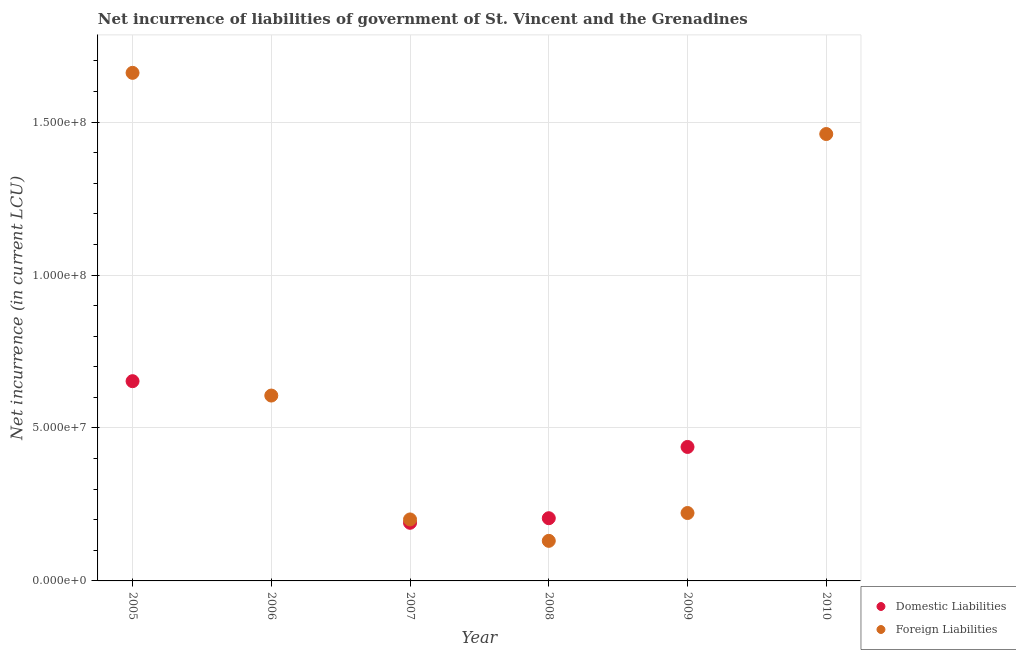Is the number of dotlines equal to the number of legend labels?
Make the answer very short. No. What is the net incurrence of foreign liabilities in 2009?
Provide a short and direct response. 2.22e+07. Across all years, what is the maximum net incurrence of foreign liabilities?
Offer a terse response. 1.66e+08. Across all years, what is the minimum net incurrence of foreign liabilities?
Ensure brevity in your answer.  1.31e+07. In which year was the net incurrence of foreign liabilities maximum?
Offer a very short reply. 2005. What is the total net incurrence of domestic liabilities in the graph?
Ensure brevity in your answer.  1.49e+08. What is the difference between the net incurrence of foreign liabilities in 2005 and that in 2006?
Ensure brevity in your answer.  1.06e+08. What is the difference between the net incurrence of foreign liabilities in 2010 and the net incurrence of domestic liabilities in 2006?
Ensure brevity in your answer.  1.46e+08. What is the average net incurrence of foreign liabilities per year?
Ensure brevity in your answer.  7.14e+07. In the year 2008, what is the difference between the net incurrence of domestic liabilities and net incurrence of foreign liabilities?
Your answer should be compact. 7.40e+06. In how many years, is the net incurrence of domestic liabilities greater than 160000000 LCU?
Your answer should be compact. 0. What is the ratio of the net incurrence of foreign liabilities in 2007 to that in 2010?
Keep it short and to the point. 0.14. Is the net incurrence of domestic liabilities in 2008 less than that in 2009?
Make the answer very short. Yes. What is the difference between the highest and the second highest net incurrence of domestic liabilities?
Offer a very short reply. 2.15e+07. What is the difference between the highest and the lowest net incurrence of foreign liabilities?
Offer a terse response. 1.53e+08. In how many years, is the net incurrence of domestic liabilities greater than the average net incurrence of domestic liabilities taken over all years?
Offer a very short reply. 2. Is the sum of the net incurrence of foreign liabilities in 2005 and 2010 greater than the maximum net incurrence of domestic liabilities across all years?
Provide a succinct answer. Yes. Does the net incurrence of foreign liabilities monotonically increase over the years?
Ensure brevity in your answer.  No. Is the net incurrence of domestic liabilities strictly greater than the net incurrence of foreign liabilities over the years?
Offer a terse response. No. Is the net incurrence of foreign liabilities strictly less than the net incurrence of domestic liabilities over the years?
Keep it short and to the point. No. What is the difference between two consecutive major ticks on the Y-axis?
Ensure brevity in your answer.  5.00e+07. Are the values on the major ticks of Y-axis written in scientific E-notation?
Your answer should be compact. Yes. What is the title of the graph?
Your response must be concise. Net incurrence of liabilities of government of St. Vincent and the Grenadines. Does "2012 US$" appear as one of the legend labels in the graph?
Provide a short and direct response. No. What is the label or title of the Y-axis?
Your answer should be compact. Net incurrence (in current LCU). What is the Net incurrence (in current LCU) in Domestic Liabilities in 2005?
Your answer should be very brief. 6.53e+07. What is the Net incurrence (in current LCU) in Foreign Liabilities in 2005?
Ensure brevity in your answer.  1.66e+08. What is the Net incurrence (in current LCU) of Domestic Liabilities in 2006?
Provide a short and direct response. 0. What is the Net incurrence (in current LCU) of Foreign Liabilities in 2006?
Provide a succinct answer. 6.06e+07. What is the Net incurrence (in current LCU) in Domestic Liabilities in 2007?
Give a very brief answer. 1.90e+07. What is the Net incurrence (in current LCU) of Foreign Liabilities in 2007?
Provide a succinct answer. 2.01e+07. What is the Net incurrence (in current LCU) in Domestic Liabilities in 2008?
Keep it short and to the point. 2.05e+07. What is the Net incurrence (in current LCU) of Foreign Liabilities in 2008?
Your answer should be compact. 1.31e+07. What is the Net incurrence (in current LCU) of Domestic Liabilities in 2009?
Keep it short and to the point. 4.38e+07. What is the Net incurrence (in current LCU) of Foreign Liabilities in 2009?
Your answer should be very brief. 2.22e+07. What is the Net incurrence (in current LCU) in Foreign Liabilities in 2010?
Your answer should be very brief. 1.46e+08. Across all years, what is the maximum Net incurrence (in current LCU) of Domestic Liabilities?
Your answer should be compact. 6.53e+07. Across all years, what is the maximum Net incurrence (in current LCU) of Foreign Liabilities?
Make the answer very short. 1.66e+08. Across all years, what is the minimum Net incurrence (in current LCU) in Domestic Liabilities?
Provide a succinct answer. 0. Across all years, what is the minimum Net incurrence (in current LCU) in Foreign Liabilities?
Make the answer very short. 1.31e+07. What is the total Net incurrence (in current LCU) in Domestic Liabilities in the graph?
Your response must be concise. 1.49e+08. What is the total Net incurrence (in current LCU) in Foreign Liabilities in the graph?
Provide a short and direct response. 4.28e+08. What is the difference between the Net incurrence (in current LCU) in Foreign Liabilities in 2005 and that in 2006?
Your answer should be very brief. 1.06e+08. What is the difference between the Net incurrence (in current LCU) in Domestic Liabilities in 2005 and that in 2007?
Ensure brevity in your answer.  4.63e+07. What is the difference between the Net incurrence (in current LCU) in Foreign Liabilities in 2005 and that in 2007?
Offer a very short reply. 1.46e+08. What is the difference between the Net incurrence (in current LCU) in Domestic Liabilities in 2005 and that in 2008?
Give a very brief answer. 4.48e+07. What is the difference between the Net incurrence (in current LCU) in Foreign Liabilities in 2005 and that in 2008?
Your answer should be very brief. 1.53e+08. What is the difference between the Net incurrence (in current LCU) in Domestic Liabilities in 2005 and that in 2009?
Your answer should be compact. 2.15e+07. What is the difference between the Net incurrence (in current LCU) in Foreign Liabilities in 2005 and that in 2009?
Provide a short and direct response. 1.44e+08. What is the difference between the Net incurrence (in current LCU) of Foreign Liabilities in 2006 and that in 2007?
Keep it short and to the point. 4.05e+07. What is the difference between the Net incurrence (in current LCU) of Foreign Liabilities in 2006 and that in 2008?
Provide a succinct answer. 4.75e+07. What is the difference between the Net incurrence (in current LCU) of Foreign Liabilities in 2006 and that in 2009?
Keep it short and to the point. 3.84e+07. What is the difference between the Net incurrence (in current LCU) of Foreign Liabilities in 2006 and that in 2010?
Your answer should be very brief. -8.55e+07. What is the difference between the Net incurrence (in current LCU) in Domestic Liabilities in 2007 and that in 2008?
Provide a succinct answer. -1.50e+06. What is the difference between the Net incurrence (in current LCU) in Foreign Liabilities in 2007 and that in 2008?
Keep it short and to the point. 7.00e+06. What is the difference between the Net incurrence (in current LCU) in Domestic Liabilities in 2007 and that in 2009?
Provide a short and direct response. -2.48e+07. What is the difference between the Net incurrence (in current LCU) of Foreign Liabilities in 2007 and that in 2009?
Ensure brevity in your answer.  -2.10e+06. What is the difference between the Net incurrence (in current LCU) in Foreign Liabilities in 2007 and that in 2010?
Keep it short and to the point. -1.26e+08. What is the difference between the Net incurrence (in current LCU) in Domestic Liabilities in 2008 and that in 2009?
Ensure brevity in your answer.  -2.33e+07. What is the difference between the Net incurrence (in current LCU) in Foreign Liabilities in 2008 and that in 2009?
Make the answer very short. -9.10e+06. What is the difference between the Net incurrence (in current LCU) of Foreign Liabilities in 2008 and that in 2010?
Make the answer very short. -1.33e+08. What is the difference between the Net incurrence (in current LCU) in Foreign Liabilities in 2009 and that in 2010?
Your response must be concise. -1.24e+08. What is the difference between the Net incurrence (in current LCU) of Domestic Liabilities in 2005 and the Net incurrence (in current LCU) of Foreign Liabilities in 2006?
Your answer should be compact. 4.70e+06. What is the difference between the Net incurrence (in current LCU) in Domestic Liabilities in 2005 and the Net incurrence (in current LCU) in Foreign Liabilities in 2007?
Your answer should be very brief. 4.52e+07. What is the difference between the Net incurrence (in current LCU) in Domestic Liabilities in 2005 and the Net incurrence (in current LCU) in Foreign Liabilities in 2008?
Your response must be concise. 5.22e+07. What is the difference between the Net incurrence (in current LCU) in Domestic Liabilities in 2005 and the Net incurrence (in current LCU) in Foreign Liabilities in 2009?
Provide a succinct answer. 4.31e+07. What is the difference between the Net incurrence (in current LCU) in Domestic Liabilities in 2005 and the Net incurrence (in current LCU) in Foreign Liabilities in 2010?
Offer a very short reply. -8.08e+07. What is the difference between the Net incurrence (in current LCU) of Domestic Liabilities in 2007 and the Net incurrence (in current LCU) of Foreign Liabilities in 2008?
Offer a terse response. 5.90e+06. What is the difference between the Net incurrence (in current LCU) of Domestic Liabilities in 2007 and the Net incurrence (in current LCU) of Foreign Liabilities in 2009?
Make the answer very short. -3.20e+06. What is the difference between the Net incurrence (in current LCU) in Domestic Liabilities in 2007 and the Net incurrence (in current LCU) in Foreign Liabilities in 2010?
Your response must be concise. -1.27e+08. What is the difference between the Net incurrence (in current LCU) of Domestic Liabilities in 2008 and the Net incurrence (in current LCU) of Foreign Liabilities in 2009?
Give a very brief answer. -1.70e+06. What is the difference between the Net incurrence (in current LCU) of Domestic Liabilities in 2008 and the Net incurrence (in current LCU) of Foreign Liabilities in 2010?
Give a very brief answer. -1.26e+08. What is the difference between the Net incurrence (in current LCU) of Domestic Liabilities in 2009 and the Net incurrence (in current LCU) of Foreign Liabilities in 2010?
Ensure brevity in your answer.  -1.02e+08. What is the average Net incurrence (in current LCU) of Domestic Liabilities per year?
Offer a very short reply. 2.48e+07. What is the average Net incurrence (in current LCU) in Foreign Liabilities per year?
Your answer should be very brief. 7.14e+07. In the year 2005, what is the difference between the Net incurrence (in current LCU) in Domestic Liabilities and Net incurrence (in current LCU) in Foreign Liabilities?
Your answer should be compact. -1.01e+08. In the year 2007, what is the difference between the Net incurrence (in current LCU) of Domestic Liabilities and Net incurrence (in current LCU) of Foreign Liabilities?
Your answer should be compact. -1.10e+06. In the year 2008, what is the difference between the Net incurrence (in current LCU) in Domestic Liabilities and Net incurrence (in current LCU) in Foreign Liabilities?
Your response must be concise. 7.40e+06. In the year 2009, what is the difference between the Net incurrence (in current LCU) of Domestic Liabilities and Net incurrence (in current LCU) of Foreign Liabilities?
Offer a very short reply. 2.16e+07. What is the ratio of the Net incurrence (in current LCU) of Foreign Liabilities in 2005 to that in 2006?
Your answer should be very brief. 2.74. What is the ratio of the Net incurrence (in current LCU) in Domestic Liabilities in 2005 to that in 2007?
Keep it short and to the point. 3.44. What is the ratio of the Net incurrence (in current LCU) in Foreign Liabilities in 2005 to that in 2007?
Ensure brevity in your answer.  8.26. What is the ratio of the Net incurrence (in current LCU) of Domestic Liabilities in 2005 to that in 2008?
Your response must be concise. 3.19. What is the ratio of the Net incurrence (in current LCU) in Foreign Liabilities in 2005 to that in 2008?
Offer a very short reply. 12.68. What is the ratio of the Net incurrence (in current LCU) in Domestic Liabilities in 2005 to that in 2009?
Your response must be concise. 1.49. What is the ratio of the Net incurrence (in current LCU) in Foreign Liabilities in 2005 to that in 2009?
Your answer should be very brief. 7.48. What is the ratio of the Net incurrence (in current LCU) in Foreign Liabilities in 2005 to that in 2010?
Offer a very short reply. 1.14. What is the ratio of the Net incurrence (in current LCU) in Foreign Liabilities in 2006 to that in 2007?
Provide a succinct answer. 3.01. What is the ratio of the Net incurrence (in current LCU) in Foreign Liabilities in 2006 to that in 2008?
Your answer should be very brief. 4.63. What is the ratio of the Net incurrence (in current LCU) of Foreign Liabilities in 2006 to that in 2009?
Ensure brevity in your answer.  2.73. What is the ratio of the Net incurrence (in current LCU) of Foreign Liabilities in 2006 to that in 2010?
Make the answer very short. 0.41. What is the ratio of the Net incurrence (in current LCU) of Domestic Liabilities in 2007 to that in 2008?
Your answer should be very brief. 0.93. What is the ratio of the Net incurrence (in current LCU) of Foreign Liabilities in 2007 to that in 2008?
Offer a very short reply. 1.53. What is the ratio of the Net incurrence (in current LCU) in Domestic Liabilities in 2007 to that in 2009?
Offer a terse response. 0.43. What is the ratio of the Net incurrence (in current LCU) of Foreign Liabilities in 2007 to that in 2009?
Offer a very short reply. 0.91. What is the ratio of the Net incurrence (in current LCU) of Foreign Liabilities in 2007 to that in 2010?
Your answer should be very brief. 0.14. What is the ratio of the Net incurrence (in current LCU) of Domestic Liabilities in 2008 to that in 2009?
Offer a very short reply. 0.47. What is the ratio of the Net incurrence (in current LCU) in Foreign Liabilities in 2008 to that in 2009?
Your response must be concise. 0.59. What is the ratio of the Net incurrence (in current LCU) in Foreign Liabilities in 2008 to that in 2010?
Offer a very short reply. 0.09. What is the ratio of the Net incurrence (in current LCU) in Foreign Liabilities in 2009 to that in 2010?
Your response must be concise. 0.15. What is the difference between the highest and the second highest Net incurrence (in current LCU) of Domestic Liabilities?
Provide a short and direct response. 2.15e+07. What is the difference between the highest and the lowest Net incurrence (in current LCU) of Domestic Liabilities?
Offer a terse response. 6.53e+07. What is the difference between the highest and the lowest Net incurrence (in current LCU) of Foreign Liabilities?
Offer a terse response. 1.53e+08. 